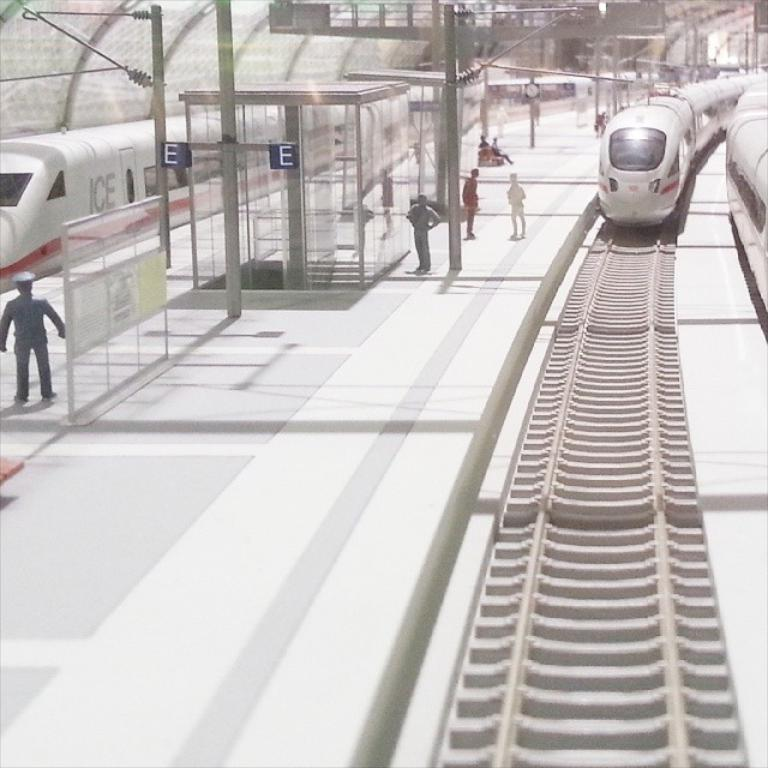<image>
Present a compact description of the photo's key features. A white high speed train is pulling up to platform E with a few people waiting for it. 